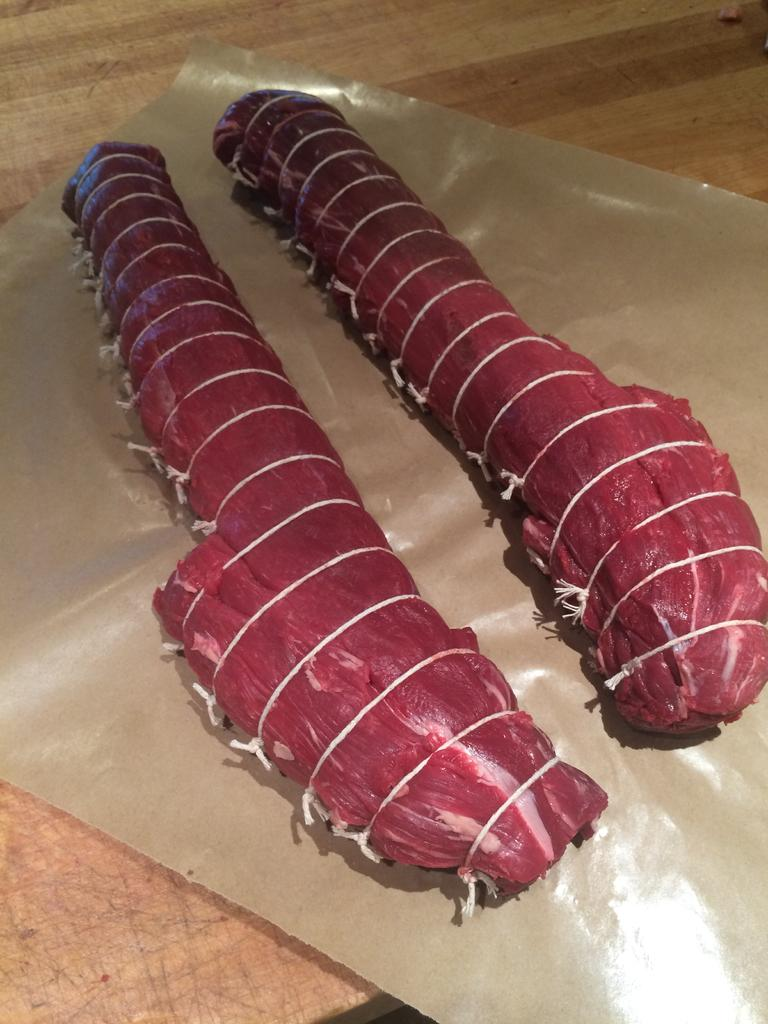What type of surface is visible in the image? There is a wooden surface in the image. Is there anything placed on the wooden surface? Yes, there is a cover on the wooden surface. What can be seen on the cover? There are two pieces of meat on the cover. How are the pieces of meat secured? The pieces of meat are tied with threads. What plot is being hatched by the boy and the mice in the image? There is no boy or mice present in the image, so there is no plot being hatched. 